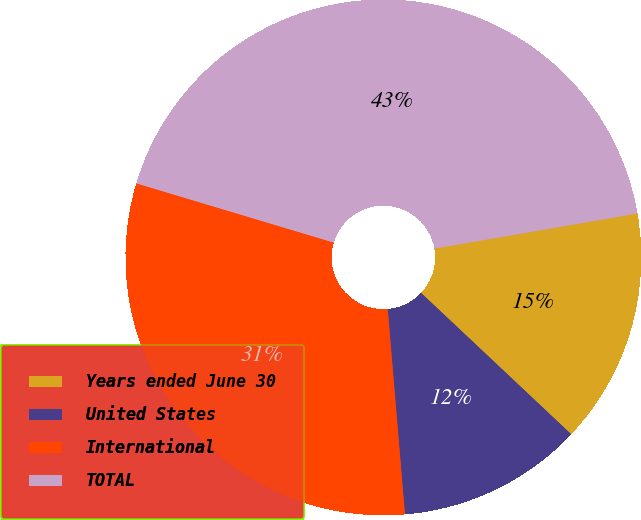Convert chart to OTSL. <chart><loc_0><loc_0><loc_500><loc_500><pie_chart><fcel>Years ended June 30<fcel>United States<fcel>International<fcel>TOTAL<nl><fcel>14.75%<fcel>11.65%<fcel>30.97%<fcel>42.63%<nl></chart> 